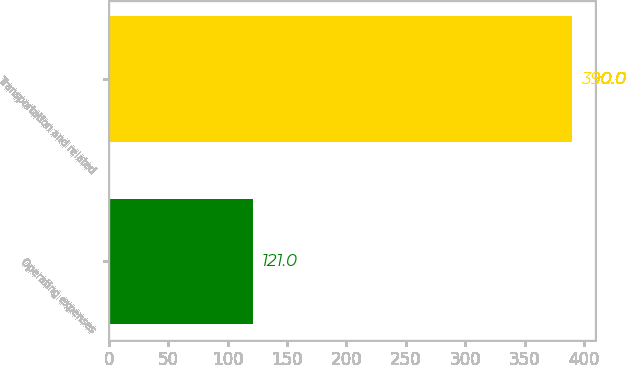Convert chart to OTSL. <chart><loc_0><loc_0><loc_500><loc_500><bar_chart><fcel>Operating expenses<fcel>Transportation and related<nl><fcel>121<fcel>390<nl></chart> 